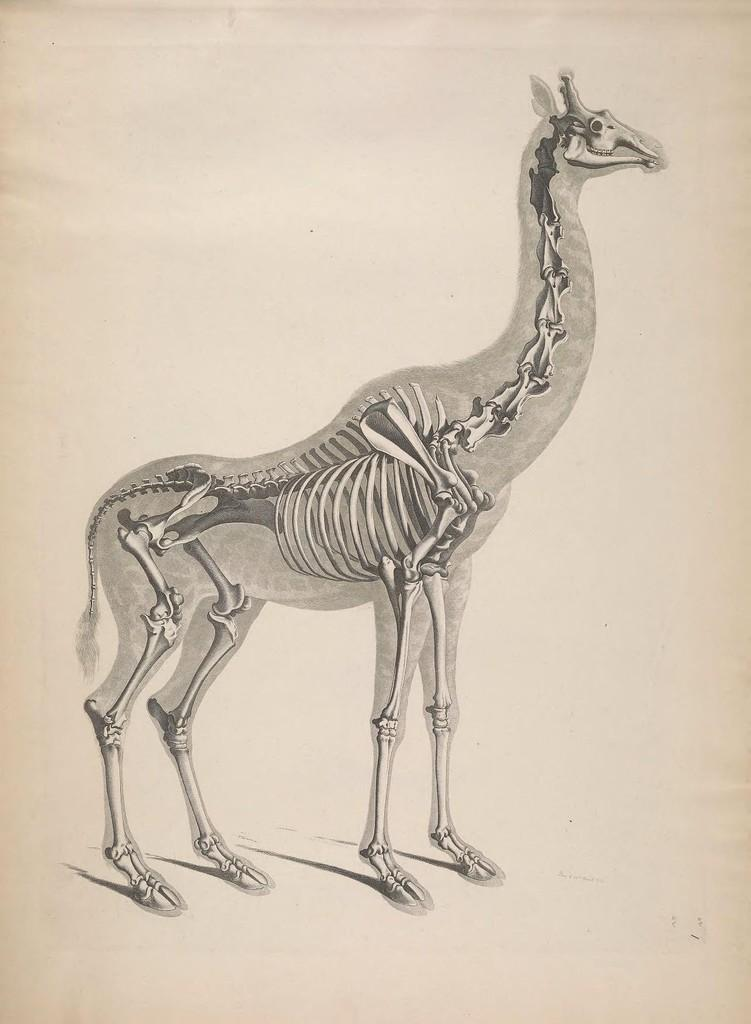What is the main subject of the image? The main subject of the image is a depiction of a skeleton. Can you describe the type of skeleton in the image? The skeleton in the image is of an animal. What type of mask is the skeleton wearing in the image? There is no mask present in the image; it is a depiction of a skeleton without any additional accessories. Who is the owner of the cracker that the skeleton is holding in the image? There is no cracker present in the image, and the skeleton is not holding any object. 